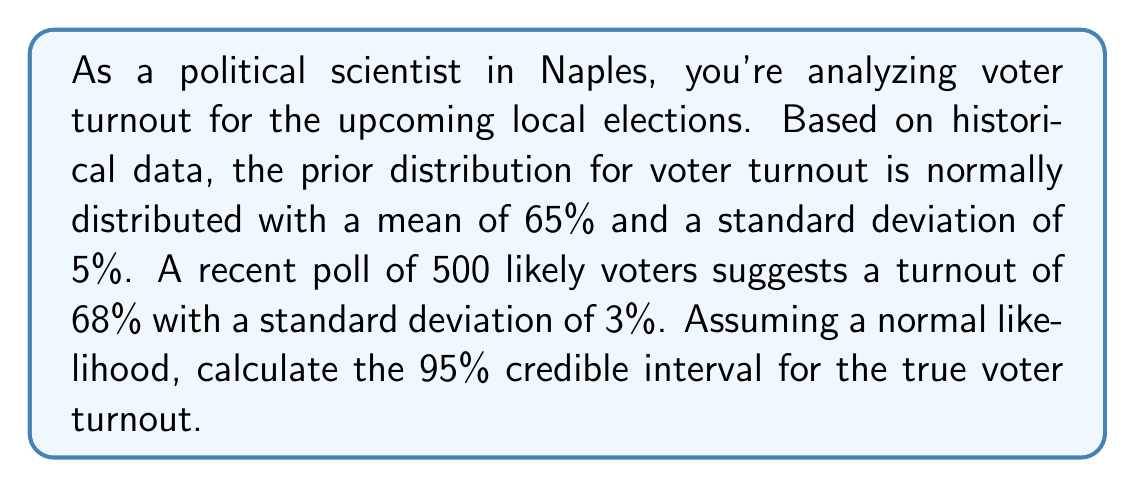Can you answer this question? To solve this problem, we'll use Bayesian updating to combine the prior information with the new poll data. We'll then calculate the credible interval for the posterior distribution.

1. Prior distribution:
   $\mu_0 = 65\%$, $\sigma_0 = 5\%$

2. Likelihood (poll data):
   $\bar{x} = 68\%$, $n = 500$, $s = 3\%$

3. Calculate the precision (inverse of variance) for prior and likelihood:
   Prior precision: $\tau_0 = \frac{1}{\sigma_0^2} = \frac{1}{0.05^2} = 400$
   Likelihood precision: $\tau = \frac{n}{s^2} = \frac{500}{0.03^2} = 555,555.56$

4. Calculate the posterior mean:
   $$\mu_n = \frac{\tau_0 \mu_0 + \tau \bar{x}}{\tau_0 + \tau}$$
   $$\mu_n = \frac{400 \cdot 0.65 + 555,555.56 \cdot 0.68}{400 + 555,555.56} = 0.6799$$

5. Calculate the posterior precision:
   $$\tau_n = \tau_0 + \tau = 400 + 555,555.56 = 555,955.56$$

6. Calculate the posterior standard deviation:
   $$\sigma_n = \sqrt{\frac{1}{\tau_n}} = \sqrt{\frac{1}{555,955.56}} = 0.00134$$

7. Calculate the 95% credible interval:
   For a 95% CI, we use ±1.96 standard deviations from the mean.
   Lower bound: $\mu_n - 1.96\sigma_n = 0.6799 - 1.96 \cdot 0.00134 = 0.6773$
   Upper bound: $\mu_n + 1.96\sigma_n = 0.6799 + 1.96 \cdot 0.00134 = 0.6825$

Therefore, the 95% credible interval for the true voter turnout is (67.73%, 68.25%).
Answer: The 95% credible interval for the true voter turnout is (67.73%, 68.25%). 